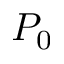<formula> <loc_0><loc_0><loc_500><loc_500>P _ { 0 }</formula> 